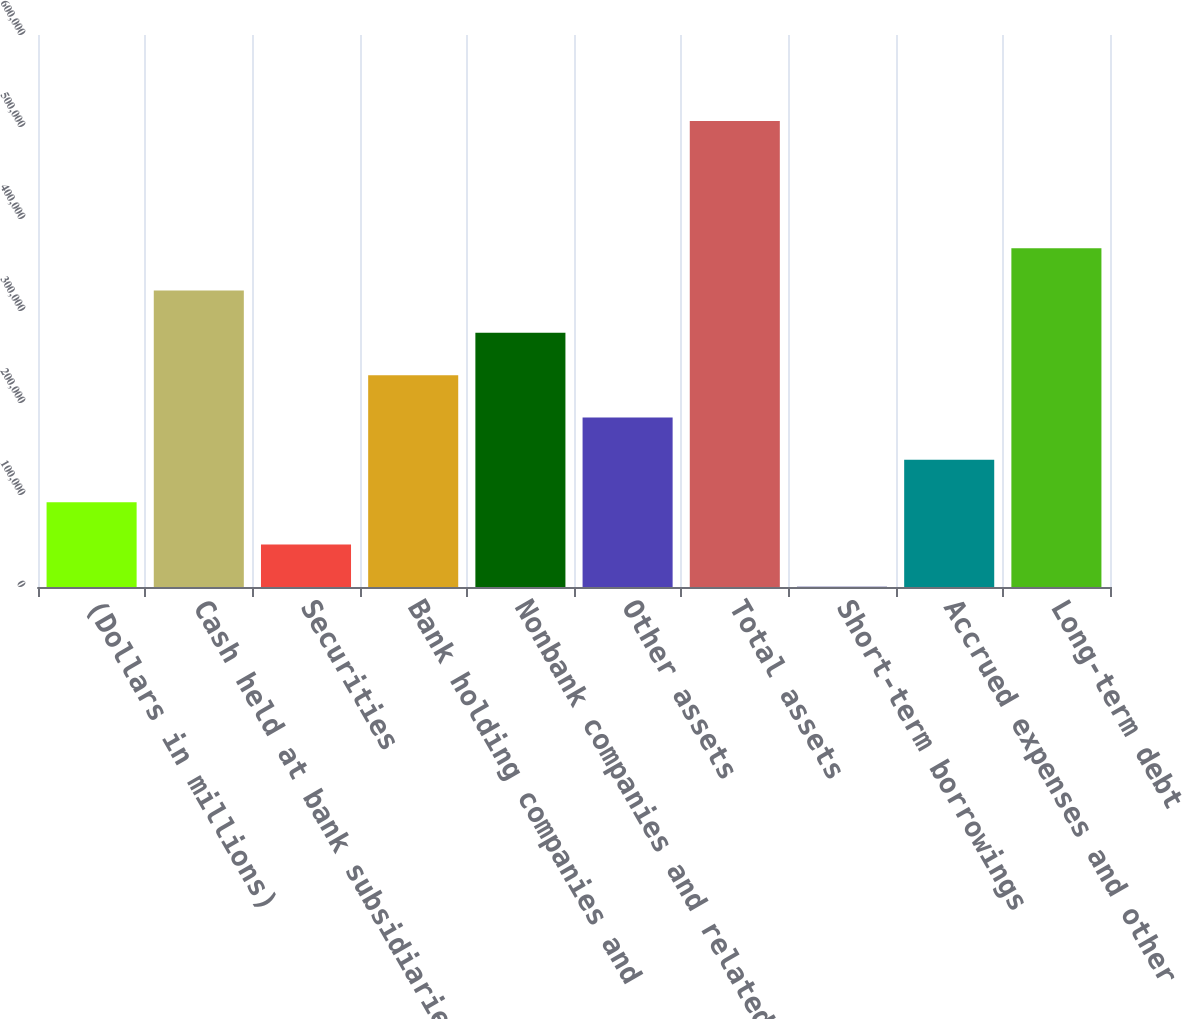Convert chart to OTSL. <chart><loc_0><loc_0><loc_500><loc_500><bar_chart><fcel>(Dollars in millions)<fcel>Cash held at bank subsidiaries<fcel>Securities<fcel>Bank holding companies and<fcel>Nonbank companies and related<fcel>Other assets<fcel>Total assets<fcel>Short-term borrowings<fcel>Accrued expenses and other<fcel>Long-term debt<nl><fcel>92218.4<fcel>322312<fcel>46199.7<fcel>230274<fcel>276293<fcel>184256<fcel>506387<fcel>181<fcel>138237<fcel>368331<nl></chart> 